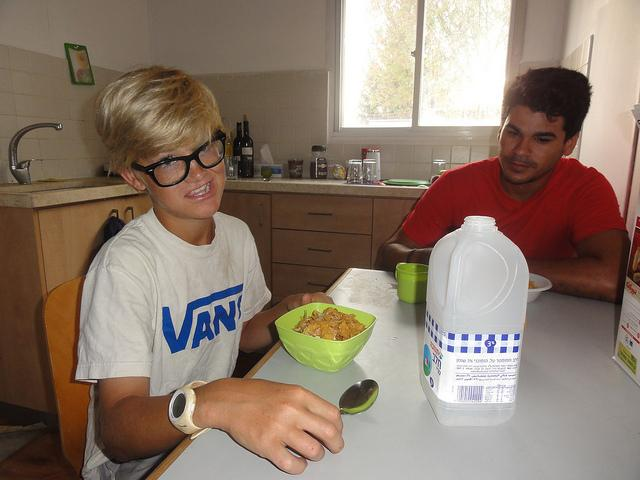What product does the young diner run out of here?

Choices:
A) vinegar
B) orange juice
C) milk
D) water milk 